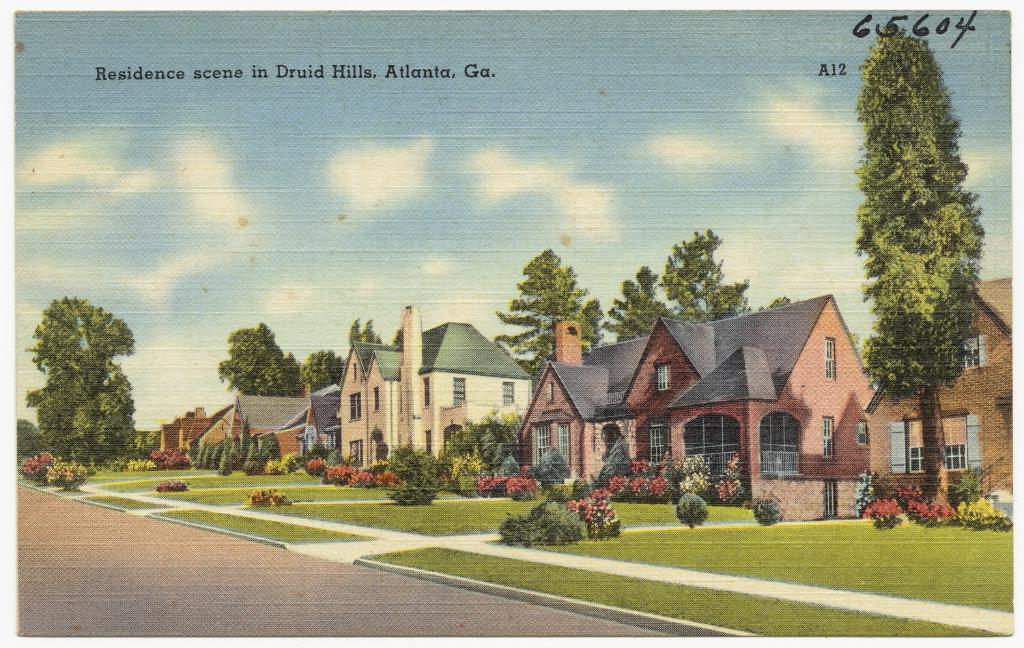What is the main subject of the image? The image contains a painting. What is depicted in the painting? The painting depicts houses, trees, and grass on the ground. Is there any text written on the image? Yes, there is text written on the image. How would you describe the sky in the painting? The sky in the image is cloudy. Can you tell me how many cows are grazing in the grass in the image? There are no cows present in the image; the painting depicts houses, trees, and grass on the ground. 